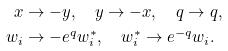Convert formula to latex. <formula><loc_0><loc_0><loc_500><loc_500>x & \to - y , \quad y \to - x , \quad q \to q , \\ w _ { i } & \to - e ^ { q } w _ { i } ^ { * } , \quad w _ { i } ^ { * } \to e ^ { - q } w _ { i } .</formula> 